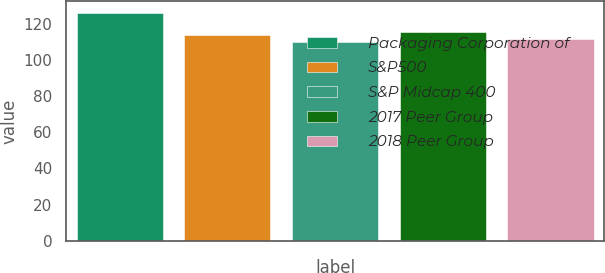<chart> <loc_0><loc_0><loc_500><loc_500><bar_chart><fcel>Packaging Corporation of<fcel>S&P500<fcel>S&P Midcap 400<fcel>2017 Peer Group<fcel>2018 Peer Group<nl><fcel>126.09<fcel>113.69<fcel>109.77<fcel>115.32<fcel>111.4<nl></chart> 